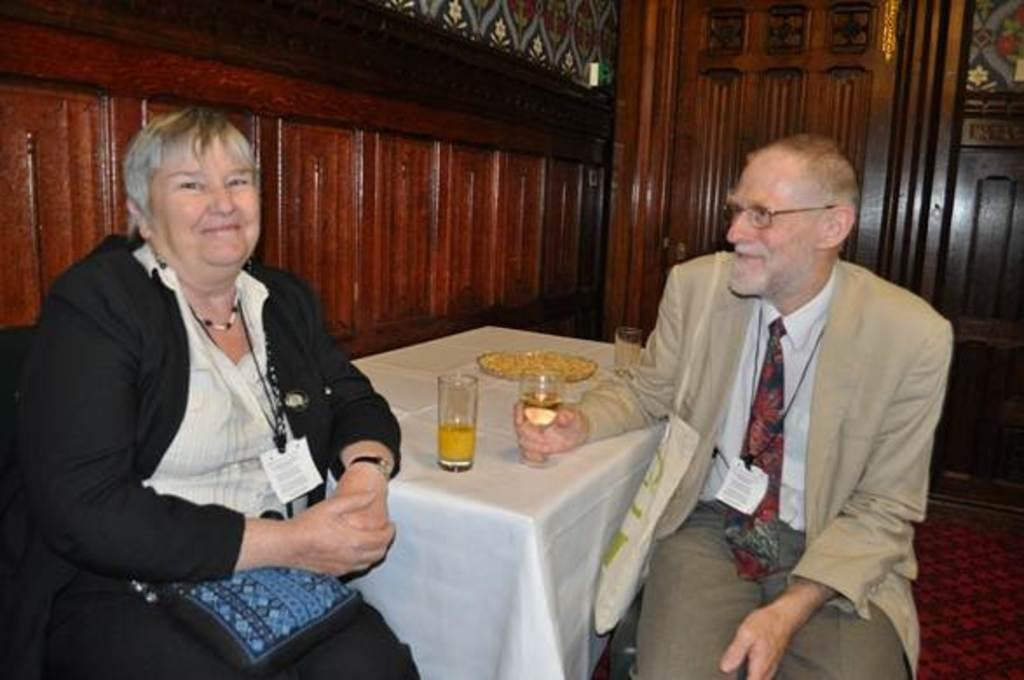How many people are in the image? There are two people in the image. What are the people doing in the image? The people are sitting on chairs. What is in front of the chairs? There is a table in front of the chairs. What items can be seen on the table? There are two glasses and a plate on the table. What is behind the people? There is a wooden wall behind the people. What feature is present in the wooden wall? There is a door in the wooden wall. What type of doll is being offered to the people in the image? There is no doll present in the image, and no one is offering anything to the people. Can you see a stream flowing behind the wooden wall in the image? There is no stream visible in the image; the focus is on the people, chairs, table, and wooden wall with a door. 